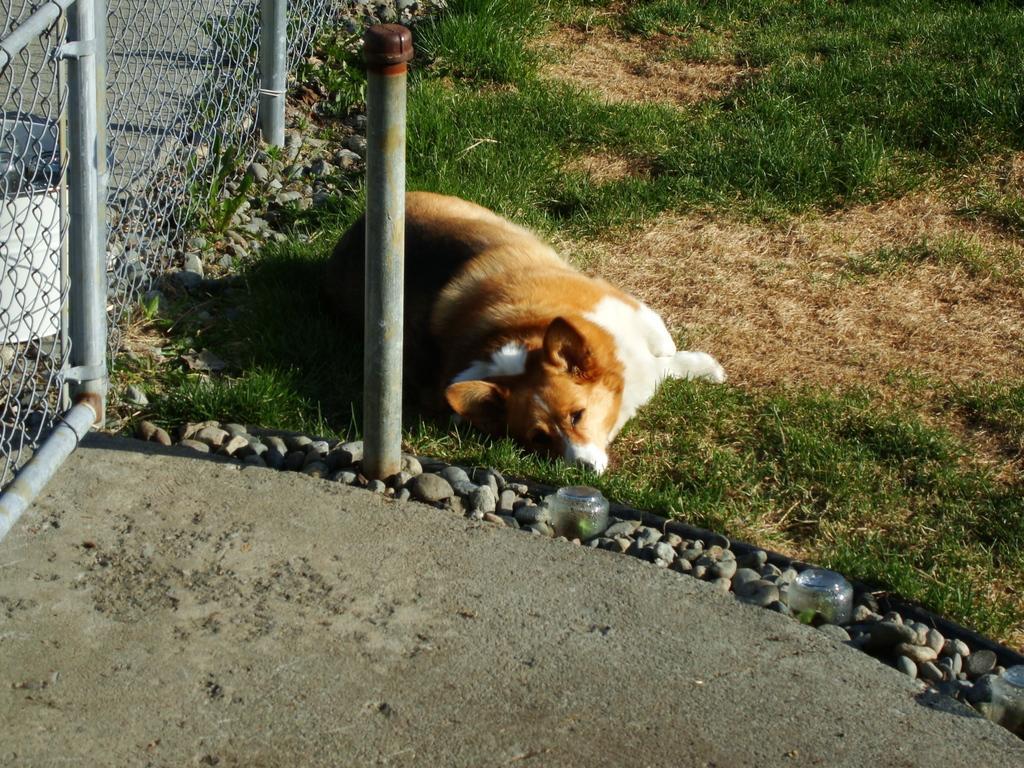How would you summarize this image in a sentence or two? In this image we can see a dog lying on the grass, stones, grill, floor and a pole. 